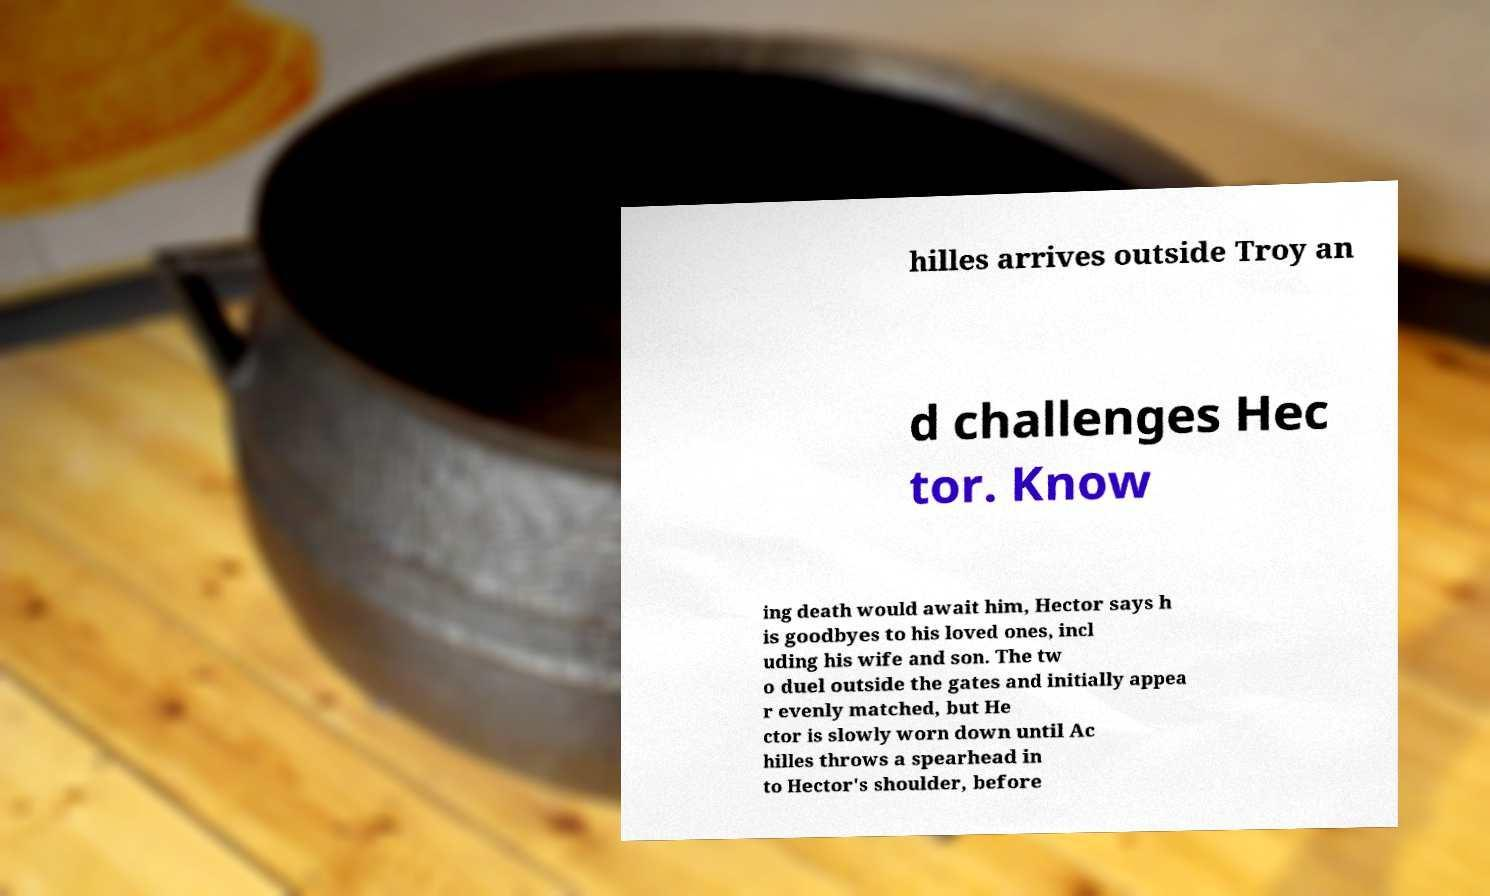Can you read and provide the text displayed in the image?This photo seems to have some interesting text. Can you extract and type it out for me? hilles arrives outside Troy an d challenges Hec tor. Know ing death would await him, Hector says h is goodbyes to his loved ones, incl uding his wife and son. The tw o duel outside the gates and initially appea r evenly matched, but He ctor is slowly worn down until Ac hilles throws a spearhead in to Hector's shoulder, before 